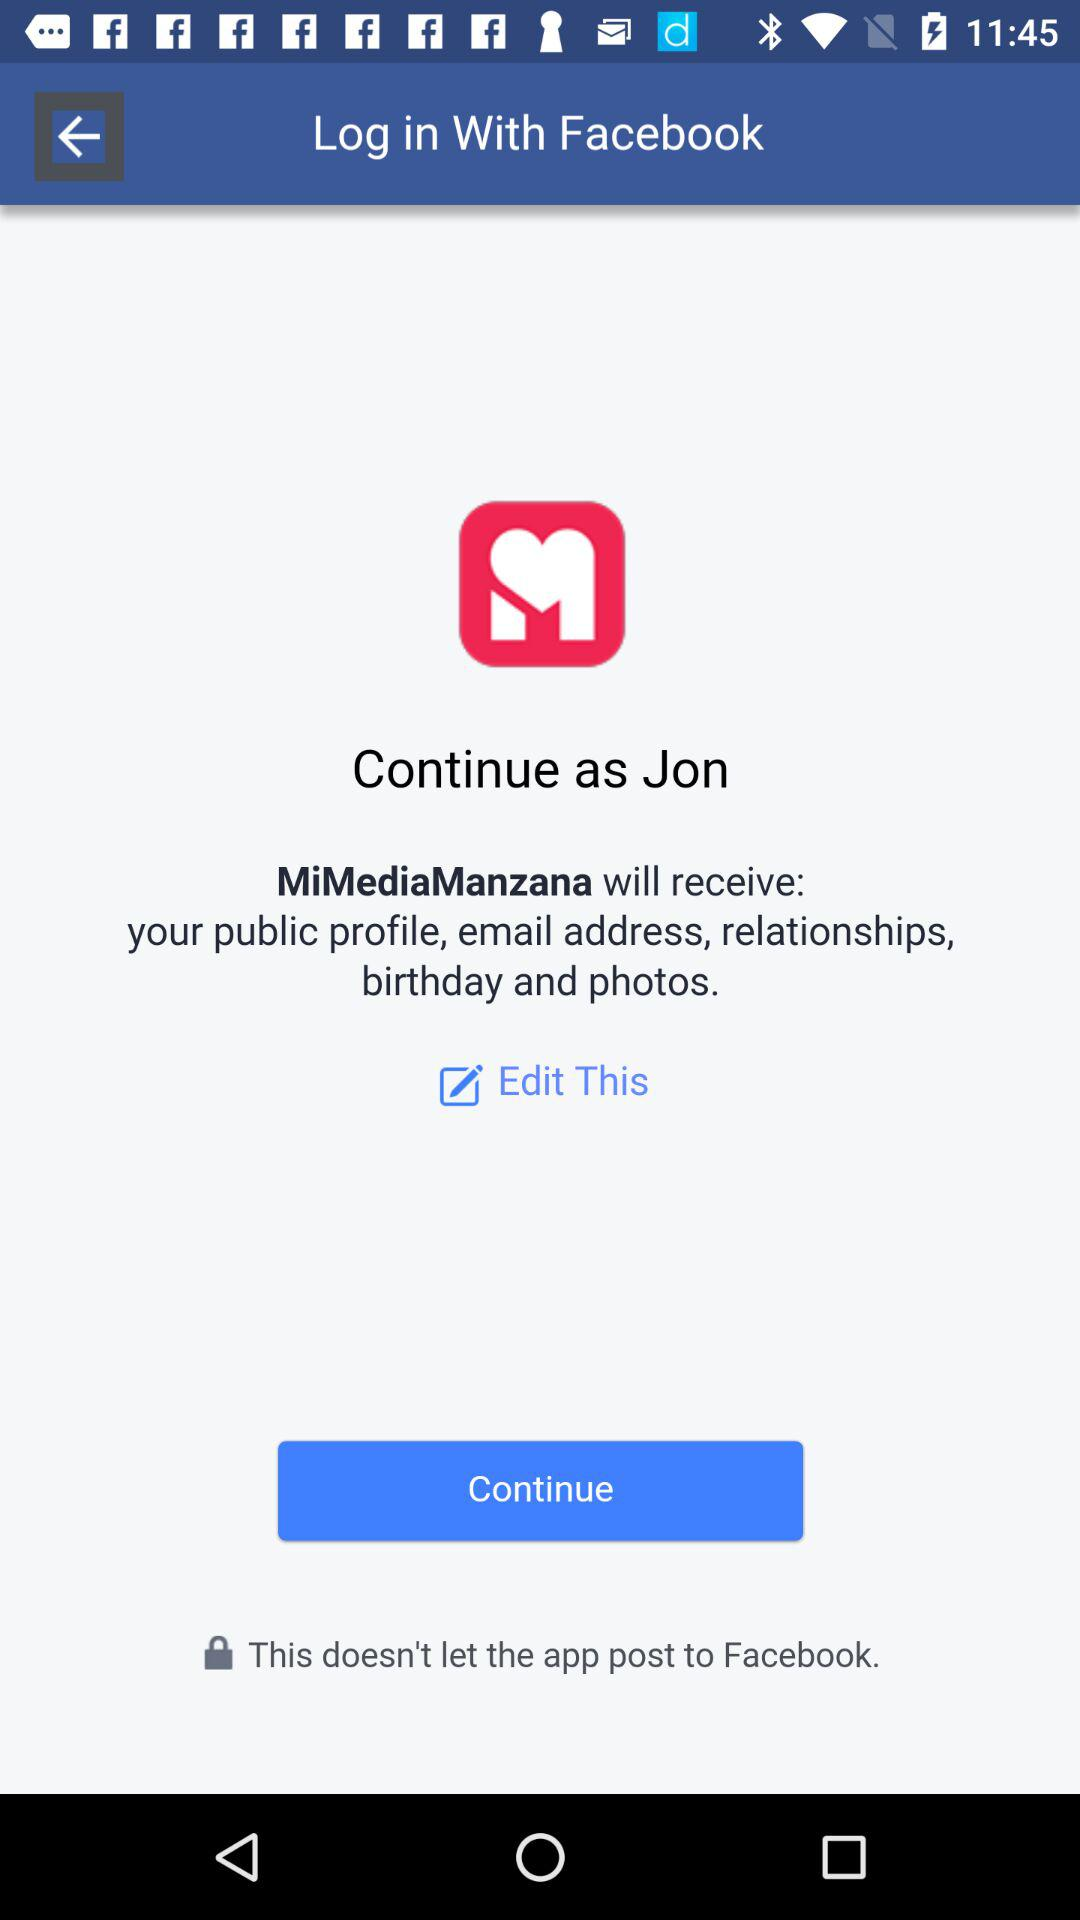Will it be edited?
When the provided information is insufficient, respond with <no answer>. <no answer> 